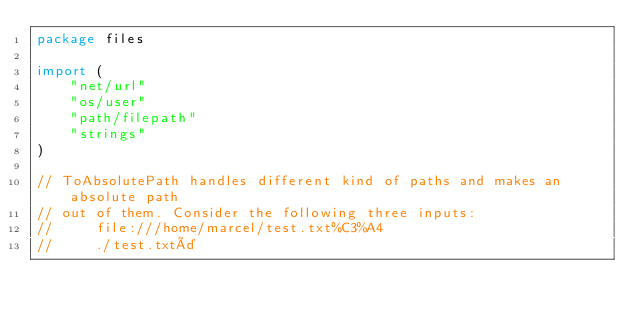<code> <loc_0><loc_0><loc_500><loc_500><_Go_>package files

import (
	"net/url"
	"os/user"
	"path/filepath"
	"strings"
)

// ToAbsolutePath handles different kind of paths and makes an absolute path
// out of them. Consider the following three inputs:
// 	   file:///home/marcel/test.txt%C3%A4
//     ./test.txtä</code> 